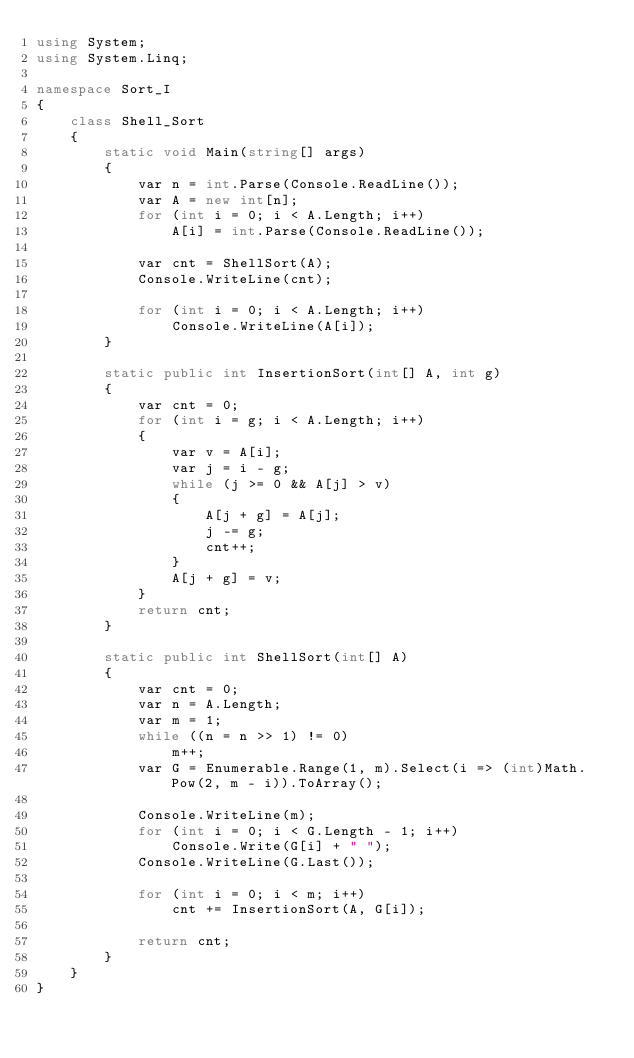Convert code to text. <code><loc_0><loc_0><loc_500><loc_500><_C#_>using System;
using System.Linq;

namespace Sort_I
{
    class Shell_Sort
    {
        static void Main(string[] args)
        {
            var n = int.Parse(Console.ReadLine());
            var A = new int[n];
            for (int i = 0; i < A.Length; i++)
                A[i] = int.Parse(Console.ReadLine());

            var cnt = ShellSort(A);
            Console.WriteLine(cnt);

            for (int i = 0; i < A.Length; i++)
                Console.WriteLine(A[i]);
        }

        static public int InsertionSort(int[] A, int g)
        {
            var cnt = 0;
            for (int i = g; i < A.Length; i++)
            {
                var v = A[i];
                var j = i - g;
                while (j >= 0 && A[j] > v)
                {
                    A[j + g] = A[j];
                    j -= g;
                    cnt++;
                }
                A[j + g] = v;
            }
            return cnt;
        }

        static public int ShellSort(int[] A)
        {
            var cnt = 0;
            var n = A.Length;
            var m = 1;
            while ((n = n >> 1) != 0)
                m++;
            var G = Enumerable.Range(1, m).Select(i => (int)Math.Pow(2, m - i)).ToArray();

            Console.WriteLine(m);
            for (int i = 0; i < G.Length - 1; i++)
                Console.Write(G[i] + " ");
            Console.WriteLine(G.Last());

            for (int i = 0; i < m; i++)
                cnt += InsertionSort(A, G[i]);

            return cnt;
        }
    }
}</code> 